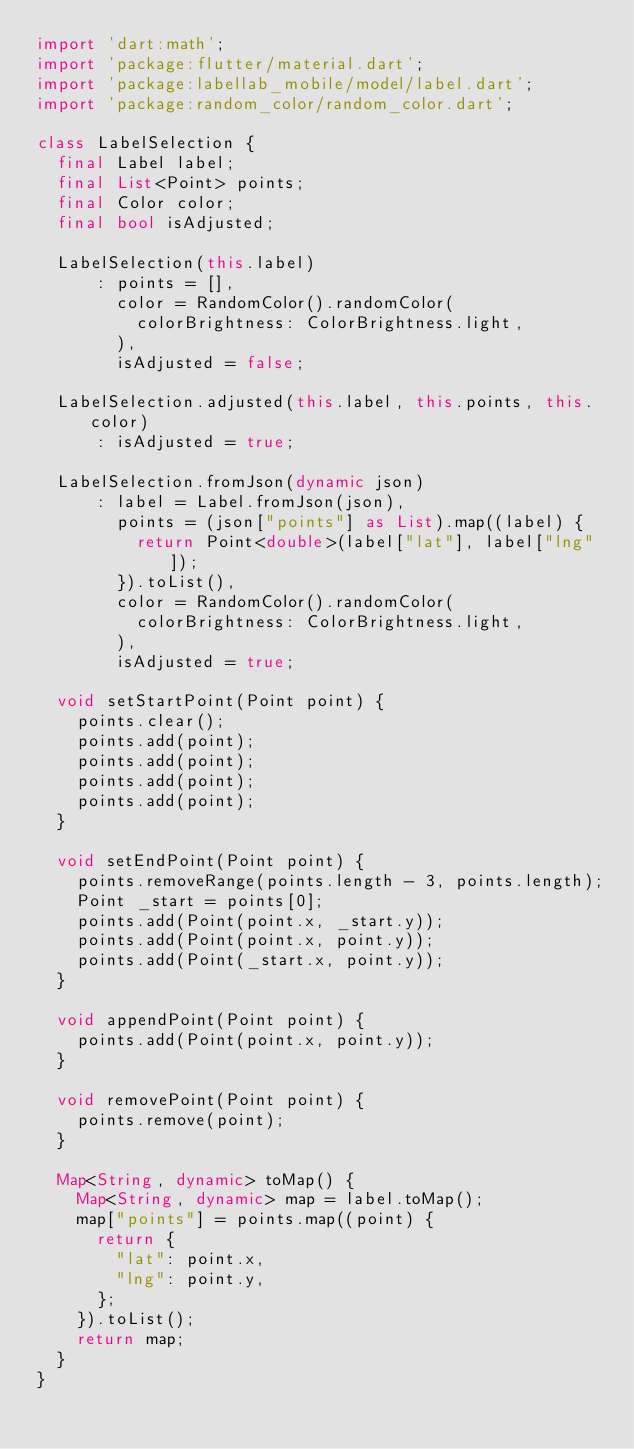<code> <loc_0><loc_0><loc_500><loc_500><_Dart_>import 'dart:math';
import 'package:flutter/material.dart';
import 'package:labellab_mobile/model/label.dart';
import 'package:random_color/random_color.dart';

class LabelSelection {
  final Label label;
  final List<Point> points;
  final Color color;
  final bool isAdjusted;

  LabelSelection(this.label)
      : points = [],
        color = RandomColor().randomColor(
          colorBrightness: ColorBrightness.light,
        ),
        isAdjusted = false;

  LabelSelection.adjusted(this.label, this.points, this.color)
      : isAdjusted = true;

  LabelSelection.fromJson(dynamic json)
      : label = Label.fromJson(json),
        points = (json["points"] as List).map((label) {
          return Point<double>(label["lat"], label["lng"]);
        }).toList(),
        color = RandomColor().randomColor(
          colorBrightness: ColorBrightness.light,
        ),
        isAdjusted = true;

  void setStartPoint(Point point) {
    points.clear();
    points.add(point);
    points.add(point);
    points.add(point);
    points.add(point);
  }

  void setEndPoint(Point point) {
    points.removeRange(points.length - 3, points.length);
    Point _start = points[0];
    points.add(Point(point.x, _start.y));
    points.add(Point(point.x, point.y));
    points.add(Point(_start.x, point.y));
  }

  void appendPoint(Point point) {
    points.add(Point(point.x, point.y));
  }

  void removePoint(Point point) {
    points.remove(point);
  }

  Map<String, dynamic> toMap() {
    Map<String, dynamic> map = label.toMap();
    map["points"] = points.map((point) {
      return {
        "lat": point.x,
        "lng": point.y,
      };
    }).toList();
    return map;
  }
}
</code> 